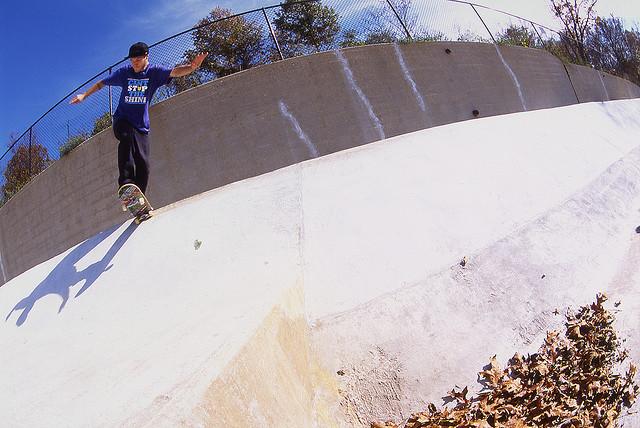Is the sun shining?
Write a very short answer. Yes. Is he skateboarding?
Keep it brief. Yes. What is at the bottom of the ramp?
Short answer required. Leaves. 